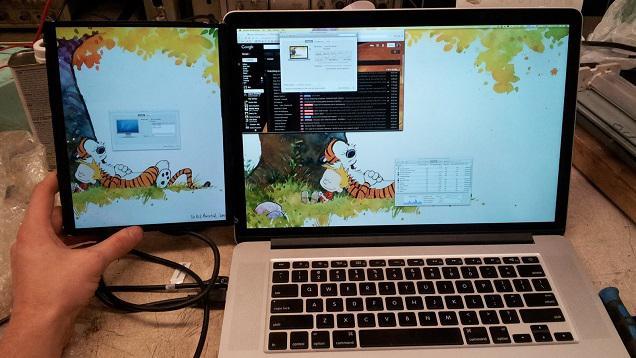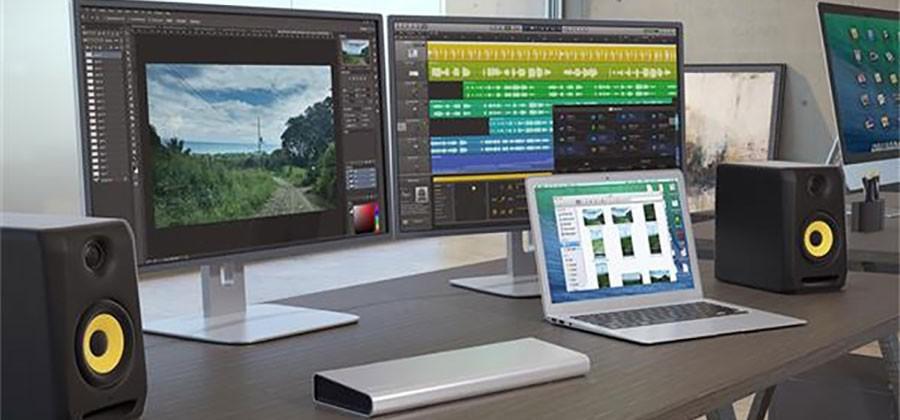The first image is the image on the left, the second image is the image on the right. Evaluate the accuracy of this statement regarding the images: "Three computer screens are lined up in each picture.". Is it true? Answer yes or no. No. 